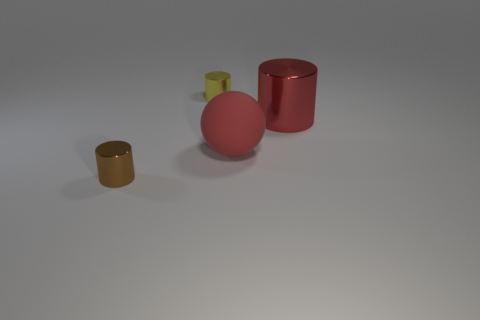Add 1 big red objects. How many objects exist? 5 Subtract all cylinders. How many objects are left? 1 Add 1 small cylinders. How many small cylinders exist? 3 Subtract 0 cyan blocks. How many objects are left? 4 Subtract all rubber things. Subtract all brown metal cylinders. How many objects are left? 2 Add 2 large cylinders. How many large cylinders are left? 3 